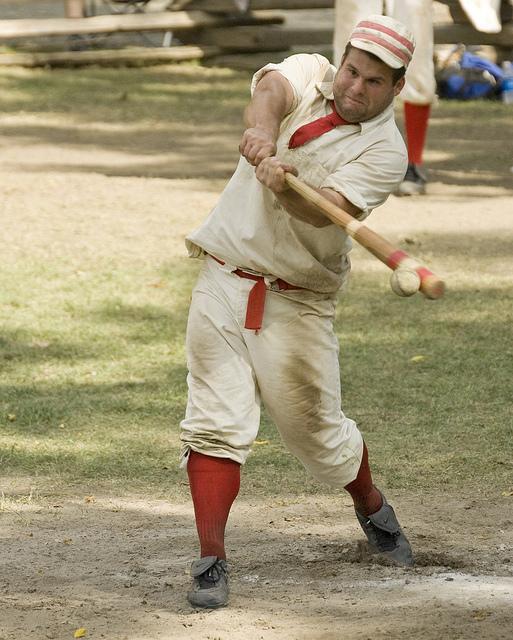How many hands does the man have?
Give a very brief answer. 2. How many people can you see?
Give a very brief answer. 2. 